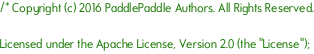<code> <loc_0><loc_0><loc_500><loc_500><_Cuda_>/* Copyright (c) 2016 PaddlePaddle Authors. All Rights Reserved.

Licensed under the Apache License, Version 2.0 (the "License");</code> 